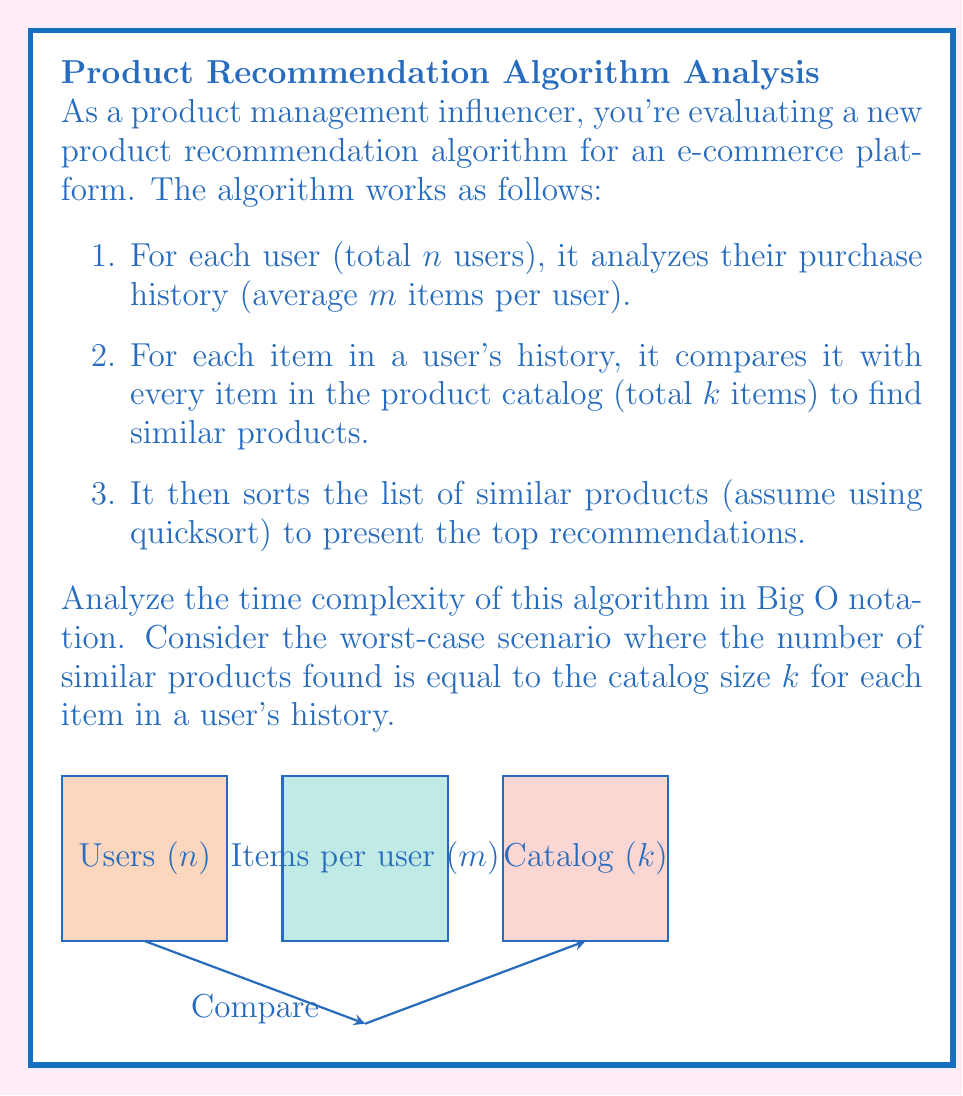Solve this math problem. Let's break down the algorithm and analyze its time complexity step by step:

1. Iterating through all users: $O(n)$

2. For each user, analyzing their purchase history: $O(m)$
   This is nested within the user loop, so we have: $O(n \cdot m)$

3. For each item in a user's history, comparing with every item in the catalog: $O(k)$
   This is nested within the purchase history loop, so we now have: $O(n \cdot m \cdot k)$

4. Sorting the list of similar products:
   - In the worst case, we're sorting $k$ items (entire catalog) for each item in the user's history
   - Quicksort has an average time complexity of $O(k \log k)$
   - This sorting is done for each item in the user's history, so we have: $O(m \cdot k \log k)$
   - This is nested within the user loop, so the total for this step is: $O(n \cdot m \cdot k \log k)$

Combining all steps, we get:
$O(n \cdot m \cdot k + n \cdot m \cdot k \log k)$

We can simplify this to:
$O(n \cdot m \cdot k \log k)$

This is because $k \log k$ is always greater than or equal to $k$ for $k \geq 2$, so the $k$ term becomes insignificant in the big picture.

Therefore, the overall time complexity of the algorithm is $O(n \cdot m \cdot k \log k)$.
Answer: $O(nmk \log k)$ 